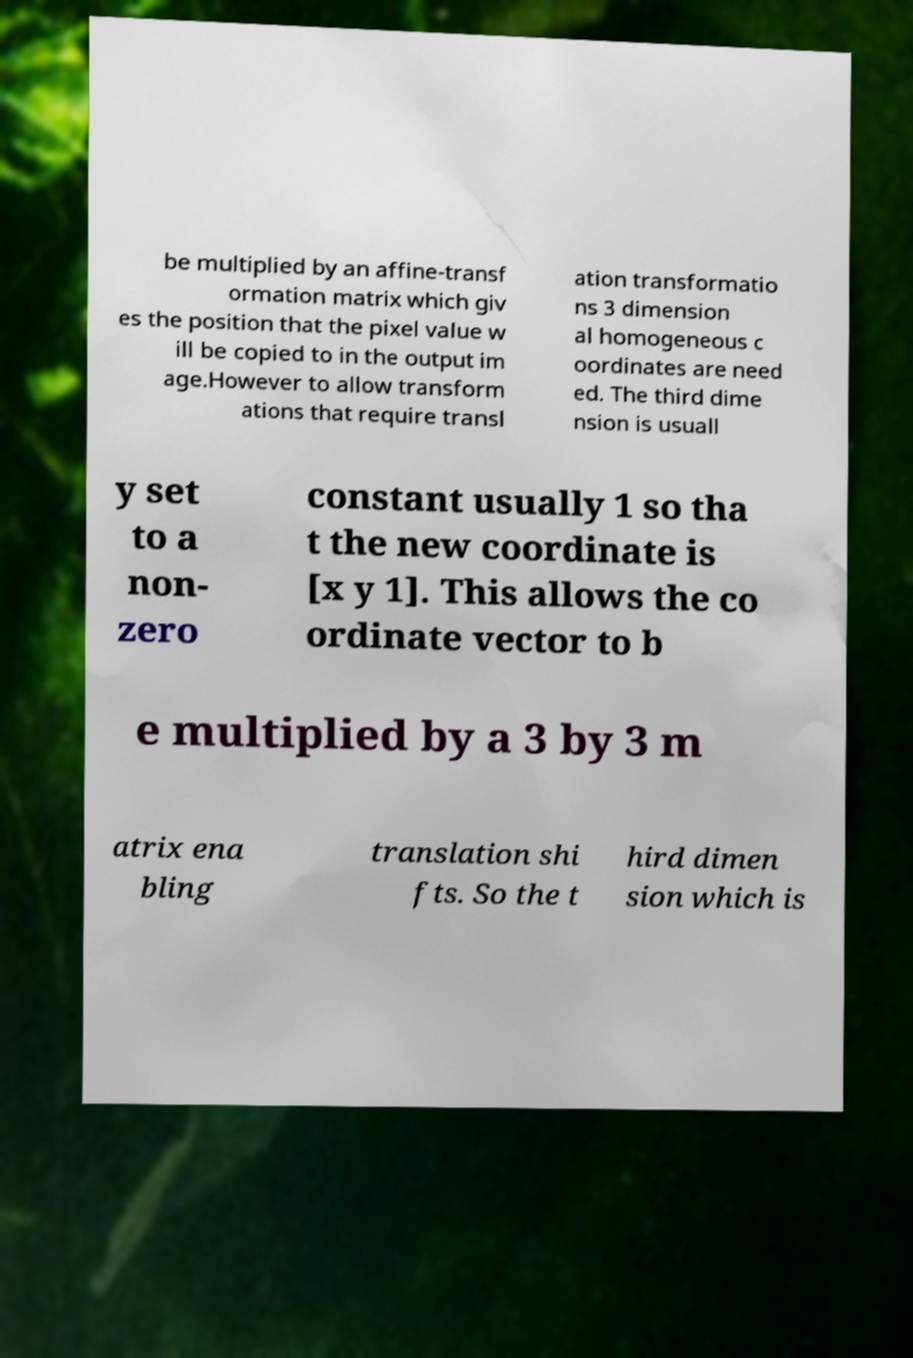Could you assist in decoding the text presented in this image and type it out clearly? be multiplied by an affine-transf ormation matrix which giv es the position that the pixel value w ill be copied to in the output im age.However to allow transform ations that require transl ation transformatio ns 3 dimension al homogeneous c oordinates are need ed. The third dime nsion is usuall y set to a non- zero constant usually 1 so tha t the new coordinate is [x y 1]. This allows the co ordinate vector to b e multiplied by a 3 by 3 m atrix ena bling translation shi fts. So the t hird dimen sion which is 